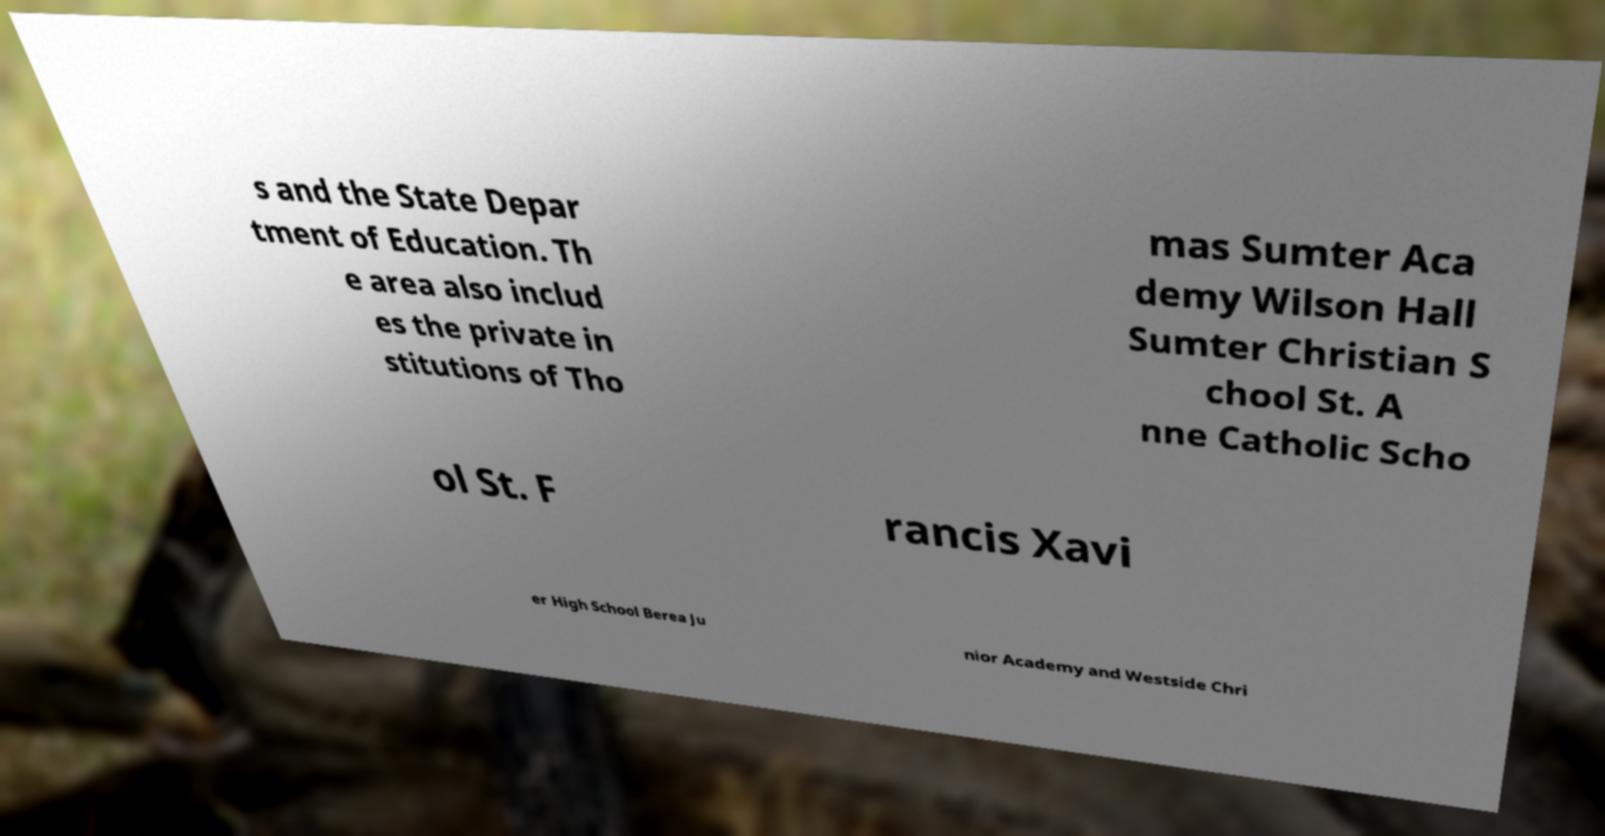Can you accurately transcribe the text from the provided image for me? s and the State Depar tment of Education. Th e area also includ es the private in stitutions of Tho mas Sumter Aca demy Wilson Hall Sumter Christian S chool St. A nne Catholic Scho ol St. F rancis Xavi er High School Berea Ju nior Academy and Westside Chri 